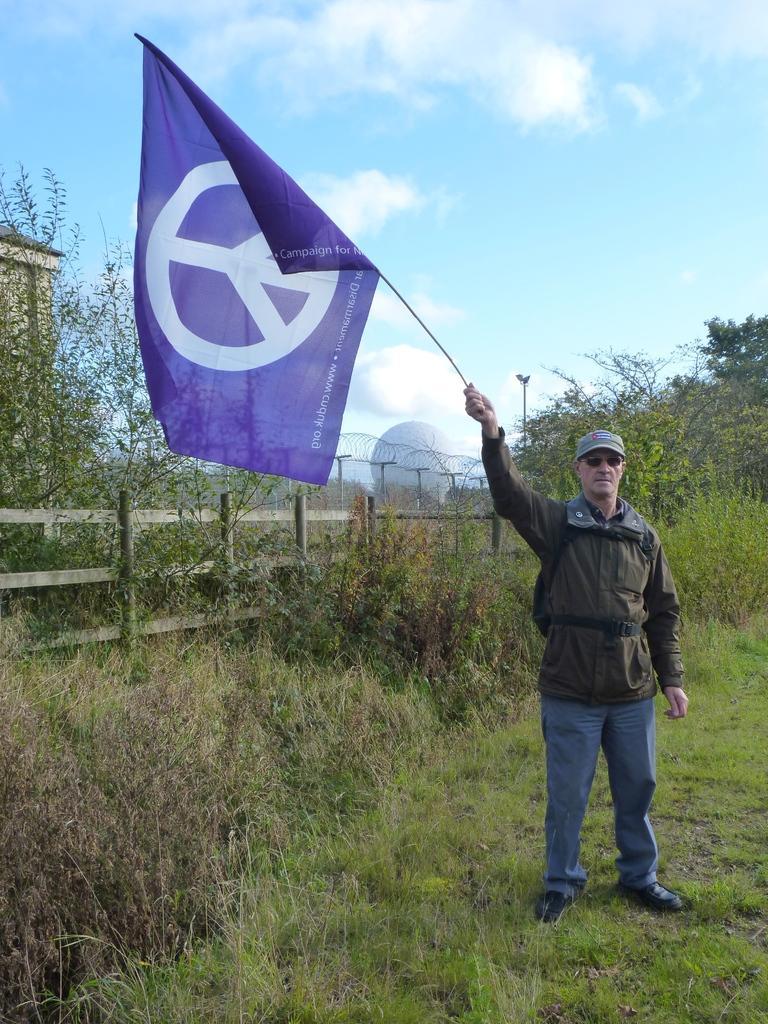In one or two sentences, can you explain what this image depicts? Land is covered with grass. This person is standing and holding a flag. Background we can see plants, fence and trees. Sky is cloudy. 